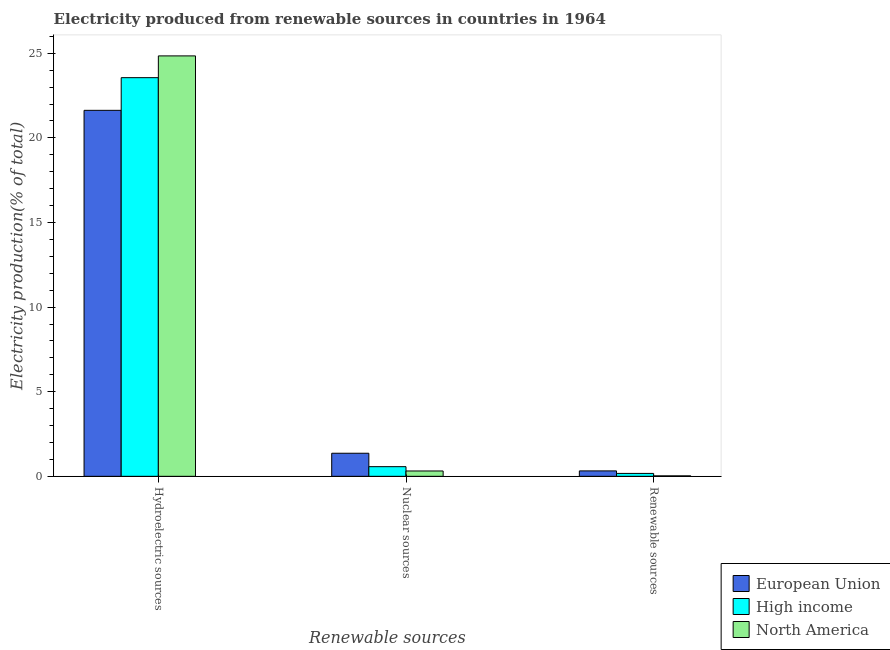How many groups of bars are there?
Ensure brevity in your answer.  3. Are the number of bars per tick equal to the number of legend labels?
Offer a very short reply. Yes. How many bars are there on the 2nd tick from the left?
Offer a terse response. 3. What is the label of the 1st group of bars from the left?
Give a very brief answer. Hydroelectric sources. What is the percentage of electricity produced by nuclear sources in High income?
Give a very brief answer. 0.57. Across all countries, what is the maximum percentage of electricity produced by nuclear sources?
Keep it short and to the point. 1.36. Across all countries, what is the minimum percentage of electricity produced by renewable sources?
Offer a terse response. 0.03. What is the total percentage of electricity produced by hydroelectric sources in the graph?
Your response must be concise. 70.03. What is the difference between the percentage of electricity produced by nuclear sources in European Union and that in High income?
Make the answer very short. 0.79. What is the difference between the percentage of electricity produced by hydroelectric sources in European Union and the percentage of electricity produced by nuclear sources in North America?
Offer a very short reply. 21.31. What is the average percentage of electricity produced by nuclear sources per country?
Ensure brevity in your answer.  0.75. What is the difference between the percentage of electricity produced by hydroelectric sources and percentage of electricity produced by renewable sources in North America?
Offer a very short reply. 24.82. In how many countries, is the percentage of electricity produced by renewable sources greater than 9 %?
Keep it short and to the point. 0. What is the ratio of the percentage of electricity produced by nuclear sources in North America to that in High income?
Provide a short and direct response. 0.55. Is the percentage of electricity produced by hydroelectric sources in North America less than that in European Union?
Provide a short and direct response. No. What is the difference between the highest and the second highest percentage of electricity produced by renewable sources?
Keep it short and to the point. 0.15. What is the difference between the highest and the lowest percentage of electricity produced by renewable sources?
Make the answer very short. 0.29. In how many countries, is the percentage of electricity produced by hydroelectric sources greater than the average percentage of electricity produced by hydroelectric sources taken over all countries?
Your answer should be compact. 2. What does the 1st bar from the left in Nuclear sources represents?
Keep it short and to the point. European Union. What does the 2nd bar from the right in Nuclear sources represents?
Your answer should be compact. High income. Is it the case that in every country, the sum of the percentage of electricity produced by hydroelectric sources and percentage of electricity produced by nuclear sources is greater than the percentage of electricity produced by renewable sources?
Keep it short and to the point. Yes. Are all the bars in the graph horizontal?
Provide a short and direct response. No. What is the difference between two consecutive major ticks on the Y-axis?
Provide a short and direct response. 5. Are the values on the major ticks of Y-axis written in scientific E-notation?
Your response must be concise. No. Does the graph contain any zero values?
Your answer should be compact. No. What is the title of the graph?
Your response must be concise. Electricity produced from renewable sources in countries in 1964. Does "Virgin Islands" appear as one of the legend labels in the graph?
Ensure brevity in your answer.  No. What is the label or title of the X-axis?
Provide a short and direct response. Renewable sources. What is the Electricity production(% of total) in European Union in Hydroelectric sources?
Offer a very short reply. 21.63. What is the Electricity production(% of total) in High income in Hydroelectric sources?
Keep it short and to the point. 23.56. What is the Electricity production(% of total) of North America in Hydroelectric sources?
Your answer should be compact. 24.84. What is the Electricity production(% of total) in European Union in Nuclear sources?
Ensure brevity in your answer.  1.36. What is the Electricity production(% of total) in High income in Nuclear sources?
Give a very brief answer. 0.57. What is the Electricity production(% of total) in North America in Nuclear sources?
Offer a very short reply. 0.32. What is the Electricity production(% of total) in European Union in Renewable sources?
Provide a short and direct response. 0.32. What is the Electricity production(% of total) in High income in Renewable sources?
Keep it short and to the point. 0.17. What is the Electricity production(% of total) in North America in Renewable sources?
Your answer should be very brief. 0.03. Across all Renewable sources, what is the maximum Electricity production(% of total) in European Union?
Offer a terse response. 21.63. Across all Renewable sources, what is the maximum Electricity production(% of total) in High income?
Ensure brevity in your answer.  23.56. Across all Renewable sources, what is the maximum Electricity production(% of total) of North America?
Provide a short and direct response. 24.84. Across all Renewable sources, what is the minimum Electricity production(% of total) of European Union?
Offer a terse response. 0.32. Across all Renewable sources, what is the minimum Electricity production(% of total) of High income?
Give a very brief answer. 0.17. Across all Renewable sources, what is the minimum Electricity production(% of total) in North America?
Your response must be concise. 0.03. What is the total Electricity production(% of total) in European Union in the graph?
Keep it short and to the point. 23.31. What is the total Electricity production(% of total) in High income in the graph?
Provide a succinct answer. 24.3. What is the total Electricity production(% of total) of North America in the graph?
Your answer should be compact. 25.19. What is the difference between the Electricity production(% of total) in European Union in Hydroelectric sources and that in Nuclear sources?
Your answer should be very brief. 20.26. What is the difference between the Electricity production(% of total) in High income in Hydroelectric sources and that in Nuclear sources?
Make the answer very short. 22.99. What is the difference between the Electricity production(% of total) in North America in Hydroelectric sources and that in Nuclear sources?
Provide a succinct answer. 24.53. What is the difference between the Electricity production(% of total) of European Union in Hydroelectric sources and that in Renewable sources?
Your answer should be very brief. 21.31. What is the difference between the Electricity production(% of total) of High income in Hydroelectric sources and that in Renewable sources?
Give a very brief answer. 23.39. What is the difference between the Electricity production(% of total) of North America in Hydroelectric sources and that in Renewable sources?
Make the answer very short. 24.82. What is the difference between the Electricity production(% of total) in European Union in Nuclear sources and that in Renewable sources?
Give a very brief answer. 1.04. What is the difference between the Electricity production(% of total) of High income in Nuclear sources and that in Renewable sources?
Provide a short and direct response. 0.4. What is the difference between the Electricity production(% of total) of North America in Nuclear sources and that in Renewable sources?
Your answer should be compact. 0.29. What is the difference between the Electricity production(% of total) of European Union in Hydroelectric sources and the Electricity production(% of total) of High income in Nuclear sources?
Offer a terse response. 21.06. What is the difference between the Electricity production(% of total) of European Union in Hydroelectric sources and the Electricity production(% of total) of North America in Nuclear sources?
Your answer should be compact. 21.31. What is the difference between the Electricity production(% of total) of High income in Hydroelectric sources and the Electricity production(% of total) of North America in Nuclear sources?
Make the answer very short. 23.24. What is the difference between the Electricity production(% of total) of European Union in Hydroelectric sources and the Electricity production(% of total) of High income in Renewable sources?
Offer a terse response. 21.46. What is the difference between the Electricity production(% of total) of European Union in Hydroelectric sources and the Electricity production(% of total) of North America in Renewable sources?
Provide a short and direct response. 21.6. What is the difference between the Electricity production(% of total) in High income in Hydroelectric sources and the Electricity production(% of total) in North America in Renewable sources?
Make the answer very short. 23.53. What is the difference between the Electricity production(% of total) of European Union in Nuclear sources and the Electricity production(% of total) of High income in Renewable sources?
Provide a succinct answer. 1.19. What is the difference between the Electricity production(% of total) of European Union in Nuclear sources and the Electricity production(% of total) of North America in Renewable sources?
Offer a very short reply. 1.34. What is the difference between the Electricity production(% of total) in High income in Nuclear sources and the Electricity production(% of total) in North America in Renewable sources?
Ensure brevity in your answer.  0.54. What is the average Electricity production(% of total) of European Union per Renewable sources?
Provide a short and direct response. 7.77. What is the average Electricity production(% of total) in High income per Renewable sources?
Keep it short and to the point. 8.1. What is the average Electricity production(% of total) of North America per Renewable sources?
Your answer should be compact. 8.4. What is the difference between the Electricity production(% of total) in European Union and Electricity production(% of total) in High income in Hydroelectric sources?
Provide a succinct answer. -1.93. What is the difference between the Electricity production(% of total) in European Union and Electricity production(% of total) in North America in Hydroelectric sources?
Provide a short and direct response. -3.22. What is the difference between the Electricity production(% of total) in High income and Electricity production(% of total) in North America in Hydroelectric sources?
Your answer should be very brief. -1.29. What is the difference between the Electricity production(% of total) in European Union and Electricity production(% of total) in High income in Nuclear sources?
Make the answer very short. 0.79. What is the difference between the Electricity production(% of total) of European Union and Electricity production(% of total) of North America in Nuclear sources?
Your response must be concise. 1.05. What is the difference between the Electricity production(% of total) of High income and Electricity production(% of total) of North America in Nuclear sources?
Ensure brevity in your answer.  0.25. What is the difference between the Electricity production(% of total) in European Union and Electricity production(% of total) in High income in Renewable sources?
Provide a short and direct response. 0.15. What is the difference between the Electricity production(% of total) of European Union and Electricity production(% of total) of North America in Renewable sources?
Provide a succinct answer. 0.29. What is the difference between the Electricity production(% of total) of High income and Electricity production(% of total) of North America in Renewable sources?
Your answer should be compact. 0.14. What is the ratio of the Electricity production(% of total) in European Union in Hydroelectric sources to that in Nuclear sources?
Offer a terse response. 15.86. What is the ratio of the Electricity production(% of total) of High income in Hydroelectric sources to that in Nuclear sources?
Provide a succinct answer. 41.32. What is the ratio of the Electricity production(% of total) in North America in Hydroelectric sources to that in Nuclear sources?
Give a very brief answer. 78.65. What is the ratio of the Electricity production(% of total) in European Union in Hydroelectric sources to that in Renewable sources?
Offer a very short reply. 67.45. What is the ratio of the Electricity production(% of total) of High income in Hydroelectric sources to that in Renewable sources?
Ensure brevity in your answer.  136.94. What is the ratio of the Electricity production(% of total) in North America in Hydroelectric sources to that in Renewable sources?
Give a very brief answer. 915.98. What is the ratio of the Electricity production(% of total) of European Union in Nuclear sources to that in Renewable sources?
Provide a succinct answer. 4.25. What is the ratio of the Electricity production(% of total) in High income in Nuclear sources to that in Renewable sources?
Keep it short and to the point. 3.31. What is the ratio of the Electricity production(% of total) of North America in Nuclear sources to that in Renewable sources?
Provide a succinct answer. 11.65. What is the difference between the highest and the second highest Electricity production(% of total) in European Union?
Your answer should be compact. 20.26. What is the difference between the highest and the second highest Electricity production(% of total) of High income?
Make the answer very short. 22.99. What is the difference between the highest and the second highest Electricity production(% of total) of North America?
Ensure brevity in your answer.  24.53. What is the difference between the highest and the lowest Electricity production(% of total) of European Union?
Give a very brief answer. 21.31. What is the difference between the highest and the lowest Electricity production(% of total) of High income?
Give a very brief answer. 23.39. What is the difference between the highest and the lowest Electricity production(% of total) of North America?
Provide a succinct answer. 24.82. 